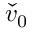Convert formula to latex. <formula><loc_0><loc_0><loc_500><loc_500>\check { v } _ { 0 }</formula> 